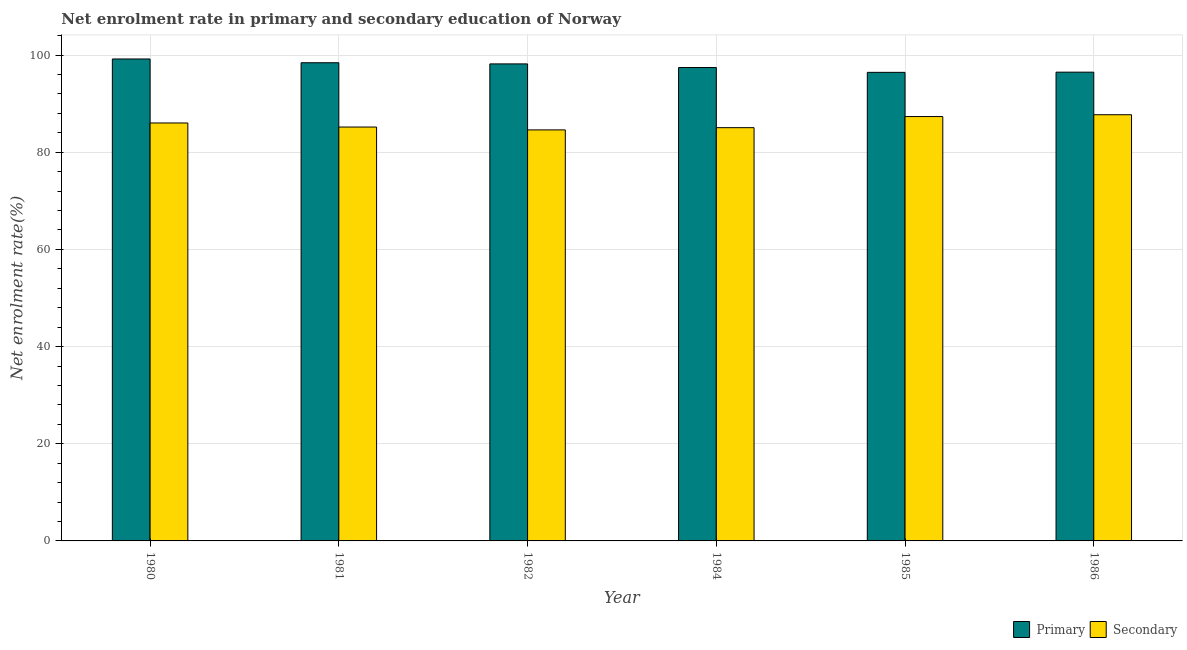How many different coloured bars are there?
Provide a succinct answer. 2. How many groups of bars are there?
Keep it short and to the point. 6. Are the number of bars per tick equal to the number of legend labels?
Offer a very short reply. Yes. Are the number of bars on each tick of the X-axis equal?
Your response must be concise. Yes. How many bars are there on the 6th tick from the left?
Provide a short and direct response. 2. What is the label of the 1st group of bars from the left?
Keep it short and to the point. 1980. What is the enrollment rate in primary education in 1980?
Give a very brief answer. 99.2. Across all years, what is the maximum enrollment rate in primary education?
Your answer should be compact. 99.2. Across all years, what is the minimum enrollment rate in secondary education?
Make the answer very short. 84.6. In which year was the enrollment rate in secondary education minimum?
Provide a short and direct response. 1982. What is the total enrollment rate in secondary education in the graph?
Offer a terse response. 515.97. What is the difference between the enrollment rate in secondary education in 1982 and that in 1986?
Your answer should be very brief. -3.12. What is the difference between the enrollment rate in secondary education in 1984 and the enrollment rate in primary education in 1986?
Ensure brevity in your answer.  -2.66. What is the average enrollment rate in primary education per year?
Your answer should be compact. 97.7. In how many years, is the enrollment rate in secondary education greater than 56 %?
Offer a very short reply. 6. What is the ratio of the enrollment rate in primary education in 1980 to that in 1984?
Provide a succinct answer. 1.02. Is the enrollment rate in secondary education in 1981 less than that in 1986?
Your answer should be very brief. Yes. What is the difference between the highest and the second highest enrollment rate in primary education?
Make the answer very short. 0.78. What is the difference between the highest and the lowest enrollment rate in secondary education?
Provide a succinct answer. 3.12. Is the sum of the enrollment rate in secondary education in 1980 and 1982 greater than the maximum enrollment rate in primary education across all years?
Offer a very short reply. Yes. What does the 2nd bar from the left in 1986 represents?
Ensure brevity in your answer.  Secondary. What does the 1st bar from the right in 1984 represents?
Offer a very short reply. Secondary. How many bars are there?
Ensure brevity in your answer.  12. Are the values on the major ticks of Y-axis written in scientific E-notation?
Make the answer very short. No. Does the graph contain any zero values?
Your response must be concise. No. Where does the legend appear in the graph?
Give a very brief answer. Bottom right. What is the title of the graph?
Provide a succinct answer. Net enrolment rate in primary and secondary education of Norway. Does "Investment in Transport" appear as one of the legend labels in the graph?
Offer a very short reply. No. What is the label or title of the X-axis?
Your response must be concise. Year. What is the label or title of the Y-axis?
Your response must be concise. Net enrolment rate(%). What is the Net enrolment rate(%) of Primary in 1980?
Ensure brevity in your answer.  99.2. What is the Net enrolment rate(%) of Secondary in 1980?
Offer a very short reply. 86.03. What is the Net enrolment rate(%) of Primary in 1981?
Make the answer very short. 98.43. What is the Net enrolment rate(%) in Secondary in 1981?
Keep it short and to the point. 85.19. What is the Net enrolment rate(%) of Primary in 1982?
Your answer should be very brief. 98.19. What is the Net enrolment rate(%) of Secondary in 1982?
Make the answer very short. 84.6. What is the Net enrolment rate(%) of Primary in 1984?
Provide a short and direct response. 97.44. What is the Net enrolment rate(%) of Secondary in 1984?
Provide a short and direct response. 85.06. What is the Net enrolment rate(%) in Primary in 1985?
Provide a succinct answer. 96.45. What is the Net enrolment rate(%) of Secondary in 1985?
Your answer should be compact. 87.35. What is the Net enrolment rate(%) of Primary in 1986?
Offer a very short reply. 96.49. What is the Net enrolment rate(%) of Secondary in 1986?
Provide a short and direct response. 87.73. Across all years, what is the maximum Net enrolment rate(%) in Primary?
Make the answer very short. 99.2. Across all years, what is the maximum Net enrolment rate(%) in Secondary?
Ensure brevity in your answer.  87.73. Across all years, what is the minimum Net enrolment rate(%) in Primary?
Provide a short and direct response. 96.45. Across all years, what is the minimum Net enrolment rate(%) of Secondary?
Ensure brevity in your answer.  84.6. What is the total Net enrolment rate(%) of Primary in the graph?
Keep it short and to the point. 586.2. What is the total Net enrolment rate(%) of Secondary in the graph?
Your response must be concise. 515.97. What is the difference between the Net enrolment rate(%) in Primary in 1980 and that in 1981?
Provide a succinct answer. 0.78. What is the difference between the Net enrolment rate(%) of Secondary in 1980 and that in 1981?
Your response must be concise. 0.84. What is the difference between the Net enrolment rate(%) of Primary in 1980 and that in 1982?
Your answer should be very brief. 1.01. What is the difference between the Net enrolment rate(%) in Secondary in 1980 and that in 1982?
Provide a short and direct response. 1.43. What is the difference between the Net enrolment rate(%) in Primary in 1980 and that in 1984?
Your response must be concise. 1.76. What is the difference between the Net enrolment rate(%) in Secondary in 1980 and that in 1984?
Make the answer very short. 0.97. What is the difference between the Net enrolment rate(%) of Primary in 1980 and that in 1985?
Provide a succinct answer. 2.75. What is the difference between the Net enrolment rate(%) of Secondary in 1980 and that in 1985?
Make the answer very short. -1.32. What is the difference between the Net enrolment rate(%) in Primary in 1980 and that in 1986?
Your response must be concise. 2.72. What is the difference between the Net enrolment rate(%) in Secondary in 1980 and that in 1986?
Give a very brief answer. -1.7. What is the difference between the Net enrolment rate(%) of Primary in 1981 and that in 1982?
Offer a very short reply. 0.24. What is the difference between the Net enrolment rate(%) in Secondary in 1981 and that in 1982?
Provide a short and direct response. 0.59. What is the difference between the Net enrolment rate(%) in Primary in 1981 and that in 1984?
Offer a terse response. 0.99. What is the difference between the Net enrolment rate(%) of Secondary in 1981 and that in 1984?
Give a very brief answer. 0.13. What is the difference between the Net enrolment rate(%) of Primary in 1981 and that in 1985?
Provide a short and direct response. 1.98. What is the difference between the Net enrolment rate(%) in Secondary in 1981 and that in 1985?
Your answer should be very brief. -2.16. What is the difference between the Net enrolment rate(%) in Primary in 1981 and that in 1986?
Your response must be concise. 1.94. What is the difference between the Net enrolment rate(%) in Secondary in 1981 and that in 1986?
Ensure brevity in your answer.  -2.53. What is the difference between the Net enrolment rate(%) of Primary in 1982 and that in 1984?
Keep it short and to the point. 0.75. What is the difference between the Net enrolment rate(%) of Secondary in 1982 and that in 1984?
Give a very brief answer. -0.46. What is the difference between the Net enrolment rate(%) in Primary in 1982 and that in 1985?
Offer a very short reply. 1.74. What is the difference between the Net enrolment rate(%) of Secondary in 1982 and that in 1985?
Provide a short and direct response. -2.75. What is the difference between the Net enrolment rate(%) of Primary in 1982 and that in 1986?
Offer a terse response. 1.7. What is the difference between the Net enrolment rate(%) in Secondary in 1982 and that in 1986?
Your response must be concise. -3.12. What is the difference between the Net enrolment rate(%) in Secondary in 1984 and that in 1985?
Provide a short and direct response. -2.29. What is the difference between the Net enrolment rate(%) in Primary in 1984 and that in 1986?
Make the answer very short. 0.95. What is the difference between the Net enrolment rate(%) in Secondary in 1984 and that in 1986?
Provide a short and direct response. -2.66. What is the difference between the Net enrolment rate(%) of Primary in 1985 and that in 1986?
Your answer should be compact. -0.04. What is the difference between the Net enrolment rate(%) of Secondary in 1985 and that in 1986?
Your response must be concise. -0.38. What is the difference between the Net enrolment rate(%) in Primary in 1980 and the Net enrolment rate(%) in Secondary in 1981?
Offer a terse response. 14.01. What is the difference between the Net enrolment rate(%) of Primary in 1980 and the Net enrolment rate(%) of Secondary in 1982?
Provide a short and direct response. 14.6. What is the difference between the Net enrolment rate(%) of Primary in 1980 and the Net enrolment rate(%) of Secondary in 1984?
Give a very brief answer. 14.14. What is the difference between the Net enrolment rate(%) in Primary in 1980 and the Net enrolment rate(%) in Secondary in 1985?
Offer a terse response. 11.85. What is the difference between the Net enrolment rate(%) in Primary in 1980 and the Net enrolment rate(%) in Secondary in 1986?
Make the answer very short. 11.47. What is the difference between the Net enrolment rate(%) in Primary in 1981 and the Net enrolment rate(%) in Secondary in 1982?
Provide a short and direct response. 13.82. What is the difference between the Net enrolment rate(%) in Primary in 1981 and the Net enrolment rate(%) in Secondary in 1984?
Keep it short and to the point. 13.36. What is the difference between the Net enrolment rate(%) in Primary in 1981 and the Net enrolment rate(%) in Secondary in 1985?
Ensure brevity in your answer.  11.08. What is the difference between the Net enrolment rate(%) of Primary in 1981 and the Net enrolment rate(%) of Secondary in 1986?
Your answer should be compact. 10.7. What is the difference between the Net enrolment rate(%) of Primary in 1982 and the Net enrolment rate(%) of Secondary in 1984?
Keep it short and to the point. 13.13. What is the difference between the Net enrolment rate(%) in Primary in 1982 and the Net enrolment rate(%) in Secondary in 1985?
Your response must be concise. 10.84. What is the difference between the Net enrolment rate(%) in Primary in 1982 and the Net enrolment rate(%) in Secondary in 1986?
Make the answer very short. 10.46. What is the difference between the Net enrolment rate(%) in Primary in 1984 and the Net enrolment rate(%) in Secondary in 1985?
Your answer should be compact. 10.09. What is the difference between the Net enrolment rate(%) in Primary in 1984 and the Net enrolment rate(%) in Secondary in 1986?
Your answer should be compact. 9.71. What is the difference between the Net enrolment rate(%) in Primary in 1985 and the Net enrolment rate(%) in Secondary in 1986?
Make the answer very short. 8.72. What is the average Net enrolment rate(%) of Primary per year?
Your answer should be very brief. 97.7. What is the average Net enrolment rate(%) in Secondary per year?
Keep it short and to the point. 86. In the year 1980, what is the difference between the Net enrolment rate(%) of Primary and Net enrolment rate(%) of Secondary?
Provide a short and direct response. 13.17. In the year 1981, what is the difference between the Net enrolment rate(%) in Primary and Net enrolment rate(%) in Secondary?
Offer a terse response. 13.23. In the year 1982, what is the difference between the Net enrolment rate(%) in Primary and Net enrolment rate(%) in Secondary?
Provide a succinct answer. 13.59. In the year 1984, what is the difference between the Net enrolment rate(%) in Primary and Net enrolment rate(%) in Secondary?
Your response must be concise. 12.38. In the year 1985, what is the difference between the Net enrolment rate(%) in Primary and Net enrolment rate(%) in Secondary?
Your answer should be very brief. 9.1. In the year 1986, what is the difference between the Net enrolment rate(%) in Primary and Net enrolment rate(%) in Secondary?
Give a very brief answer. 8.76. What is the ratio of the Net enrolment rate(%) in Primary in 1980 to that in 1981?
Provide a succinct answer. 1.01. What is the ratio of the Net enrolment rate(%) in Secondary in 1980 to that in 1981?
Ensure brevity in your answer.  1.01. What is the ratio of the Net enrolment rate(%) in Primary in 1980 to that in 1982?
Ensure brevity in your answer.  1.01. What is the ratio of the Net enrolment rate(%) in Secondary in 1980 to that in 1982?
Offer a very short reply. 1.02. What is the ratio of the Net enrolment rate(%) of Primary in 1980 to that in 1984?
Offer a terse response. 1.02. What is the ratio of the Net enrolment rate(%) of Secondary in 1980 to that in 1984?
Ensure brevity in your answer.  1.01. What is the ratio of the Net enrolment rate(%) in Primary in 1980 to that in 1985?
Provide a short and direct response. 1.03. What is the ratio of the Net enrolment rate(%) in Secondary in 1980 to that in 1985?
Provide a short and direct response. 0.98. What is the ratio of the Net enrolment rate(%) in Primary in 1980 to that in 1986?
Your response must be concise. 1.03. What is the ratio of the Net enrolment rate(%) of Secondary in 1980 to that in 1986?
Give a very brief answer. 0.98. What is the ratio of the Net enrolment rate(%) of Primary in 1981 to that in 1982?
Offer a terse response. 1. What is the ratio of the Net enrolment rate(%) of Secondary in 1981 to that in 1982?
Offer a very short reply. 1.01. What is the ratio of the Net enrolment rate(%) in Secondary in 1981 to that in 1984?
Make the answer very short. 1. What is the ratio of the Net enrolment rate(%) in Primary in 1981 to that in 1985?
Make the answer very short. 1.02. What is the ratio of the Net enrolment rate(%) of Secondary in 1981 to that in 1985?
Offer a terse response. 0.98. What is the ratio of the Net enrolment rate(%) in Primary in 1981 to that in 1986?
Your answer should be very brief. 1.02. What is the ratio of the Net enrolment rate(%) of Secondary in 1981 to that in 1986?
Your answer should be very brief. 0.97. What is the ratio of the Net enrolment rate(%) of Primary in 1982 to that in 1984?
Provide a succinct answer. 1.01. What is the ratio of the Net enrolment rate(%) in Secondary in 1982 to that in 1984?
Offer a terse response. 0.99. What is the ratio of the Net enrolment rate(%) of Primary in 1982 to that in 1985?
Provide a succinct answer. 1.02. What is the ratio of the Net enrolment rate(%) of Secondary in 1982 to that in 1985?
Your answer should be very brief. 0.97. What is the ratio of the Net enrolment rate(%) of Primary in 1982 to that in 1986?
Provide a short and direct response. 1.02. What is the ratio of the Net enrolment rate(%) of Secondary in 1982 to that in 1986?
Ensure brevity in your answer.  0.96. What is the ratio of the Net enrolment rate(%) in Primary in 1984 to that in 1985?
Your response must be concise. 1.01. What is the ratio of the Net enrolment rate(%) in Secondary in 1984 to that in 1985?
Provide a short and direct response. 0.97. What is the ratio of the Net enrolment rate(%) in Primary in 1984 to that in 1986?
Your answer should be compact. 1.01. What is the ratio of the Net enrolment rate(%) of Secondary in 1984 to that in 1986?
Ensure brevity in your answer.  0.97. What is the ratio of the Net enrolment rate(%) of Primary in 1985 to that in 1986?
Provide a short and direct response. 1. What is the difference between the highest and the second highest Net enrolment rate(%) of Primary?
Offer a terse response. 0.78. What is the difference between the highest and the second highest Net enrolment rate(%) in Secondary?
Ensure brevity in your answer.  0.38. What is the difference between the highest and the lowest Net enrolment rate(%) in Primary?
Ensure brevity in your answer.  2.75. What is the difference between the highest and the lowest Net enrolment rate(%) of Secondary?
Provide a succinct answer. 3.12. 